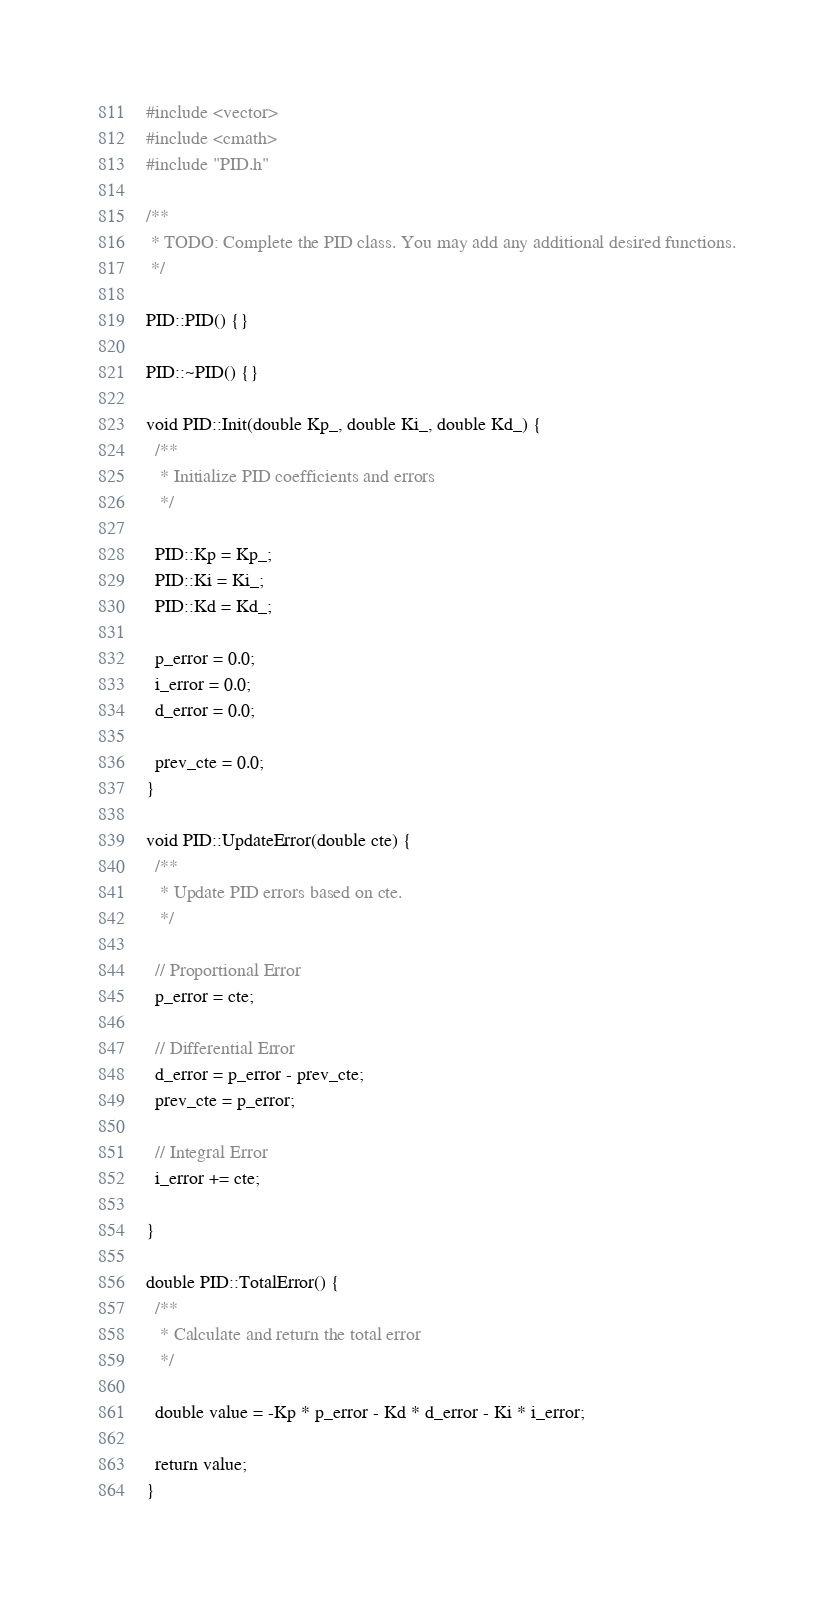<code> <loc_0><loc_0><loc_500><loc_500><_C++_>#include <vector>
#include <cmath>
#include "PID.h"

/**
 * TODO: Complete the PID class. You may add any additional desired functions.
 */

PID::PID() {}

PID::~PID() {}

void PID::Init(double Kp_, double Ki_, double Kd_) {
  /**
   * Initialize PID coefficients and errors
   */

  PID::Kp = Kp_;
  PID::Ki = Ki_;
  PID::Kd = Kd_;

  p_error = 0.0;
  i_error = 0.0;
  d_error = 0.0;

  prev_cte = 0.0;
}

void PID::UpdateError(double cte) {
  /**
   * Update PID errors based on cte.
   */

  // Proportional Error
  p_error = cte;

  // Differential Error
  d_error = p_error - prev_cte;
  prev_cte = p_error;

  // Integral Error
  i_error += cte;

}

double PID::TotalError() {
  /**
   * Calculate and return the total error
   */

  double value = -Kp * p_error - Kd * d_error - Ki * i_error;

  return value;  
}</code> 